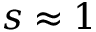<formula> <loc_0><loc_0><loc_500><loc_500>s \approx 1</formula> 